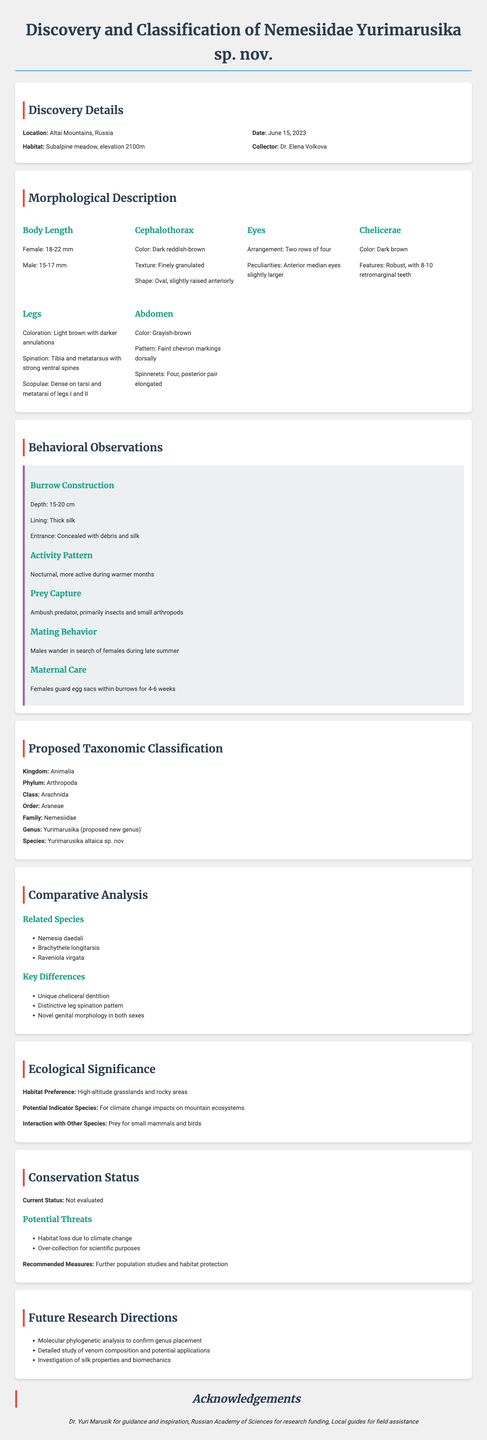what is the title of the report? The title of the report is stated at the beginning of the document.
Answer: Discovery and Classification of Nemesiidae Yurimarusika sp. nov who collected the new spider species? The collector's name is mentioned in the discovery details section of the report.
Answer: Dr. Elena Volkova how many pairs of spinnerets does the spider have? The number of spinnerets is mentioned in the morphological description section.
Answer: Four what is the primary activity pattern of the spider? The activity pattern is described in the behavioral observations section.
Answer: Nocturnal which genus is proposed for this new species? The proposed genus is specified in the taxonomic classification section of the report.
Answer: Yurimarusika what are two potential threats to the species? The potential threats are listed in the conservation status section and require identifying threats explicitly mentioned.
Answer: Habitat loss, Over-collection what is the main ecological role of the spider in its habitat? The ecological significance highlights the spider's role within its ecosystem, which involves its interactions with other species.
Answer: Indicator species name one related species mentioned in the report. Related species are listed in the comparative analysis section.
Answer: Nemesia daedali 